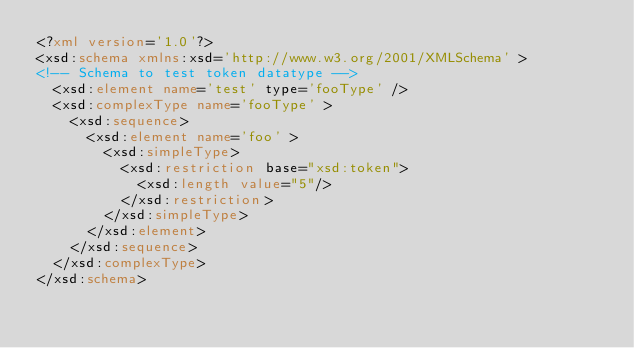<code> <loc_0><loc_0><loc_500><loc_500><_XML_><?xml version='1.0'?>
<xsd:schema xmlns:xsd='http://www.w3.org/2001/XMLSchema' >
<!-- Schema to test token datatype -->
  <xsd:element name='test' type='fooType' />
  <xsd:complexType name='fooType' > 
    <xsd:sequence>
      <xsd:element name='foo' >
        <xsd:simpleType>
          <xsd:restriction base="xsd:token">
            <xsd:length value="5"/>
          </xsd:restriction>
        </xsd:simpleType>
      </xsd:element>
    </xsd:sequence>
  </xsd:complexType>
</xsd:schema>
</code> 